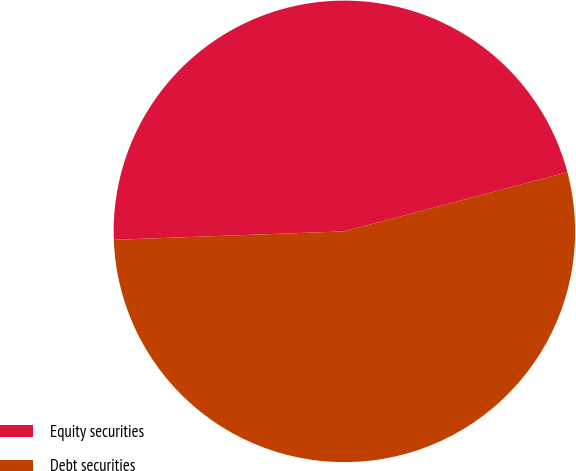Convert chart to OTSL. <chart><loc_0><loc_0><loc_500><loc_500><pie_chart><fcel>Equity securities<fcel>Debt securities<nl><fcel>46.46%<fcel>53.54%<nl></chart> 